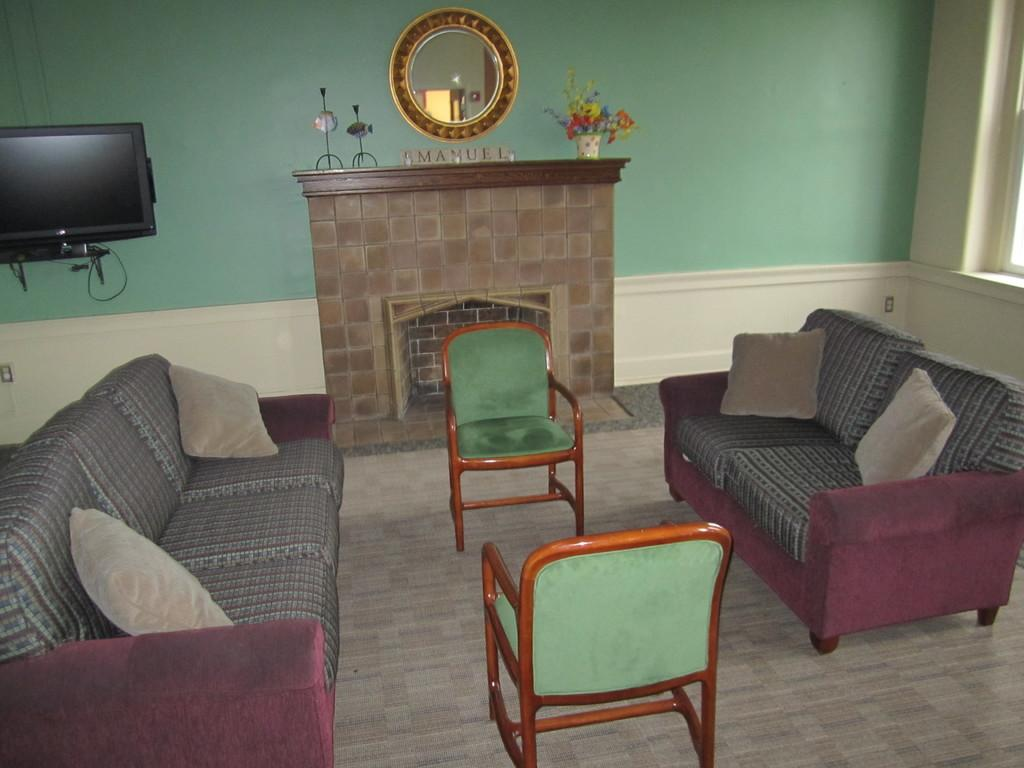What type of furniture is in the room? There is a sofa and two chairs in the room. Where are the chairs located in the room? The two chairs are in the center of the room. What is at the back of the room? There is a mirror at the back of the room. What type of electronic device is on the left side of the room? There is a television on the left side of the room. What type of arithmetic problem is being solved on the television in the image? There is no arithmetic problem being solved on the television in the image; it is a regular television. Are there any bikes visible in the room? There are no bikes present in the room. 